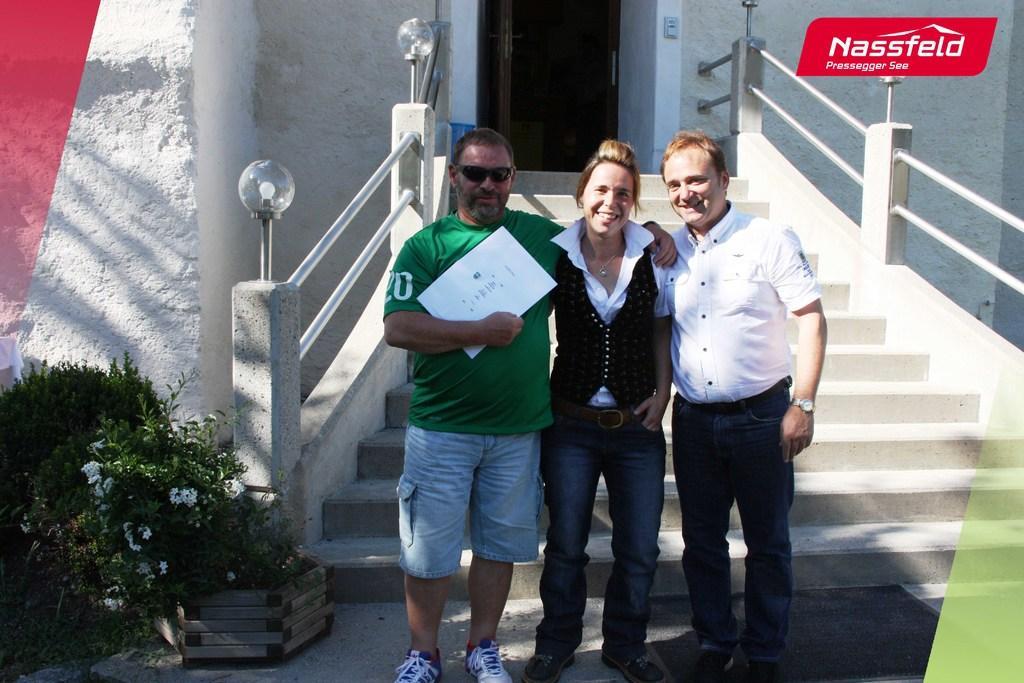Can you describe this image briefly? In this image we can see three persons standing. Person on the right is wearing watch. Person on the left is holding something in the hand and wearing goggles. In the back there are steps with railings. In the background there are walls. On the left side there are plants with flowers and there is a basket. In the right top corner there is a watermark. 